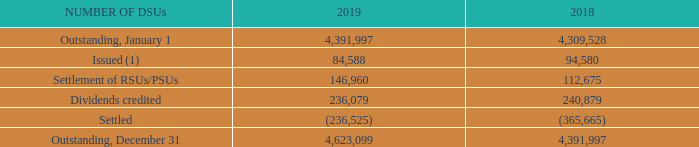DSUs
Eligible bonuses and RSUs/PSUs may be paid in the form of DSUs when executives or other eligible employees elect to or are required to participate in the plan. The value of a DSU at the issuance date is equal to the value of one BCE common share. For non-management directors, compensation is paid in DSUs until the minimum share ownership requirement is met; thereafter, at least 50% of their compensation is paid in DSUs. There are no vesting requirements relating to DSUs. Dividends in the form of additional DSUs are credited to the participant’s account on each dividend payment date and are equivalent in value to the dividends paid on BCE common shares. DSUs are settled when the holder leaves the company.
The following table summarizes the status of outstanding DSUs at December 31, 2019 and 2018.
(1) The weighted average fair value of the DSUs issued was $59 in 2019 and $55 in 2018.
Which years does the table summarize the status of outstanding DSUs? 2019, 2018. What is the value of a DSU at the issuance date? Equal to the value of one bce common share. What is the weighted average fair value of the DSUs issued in 2018? $55. In which year is the amount of Issued DSUs larger? 84,588<94,580
Answer: 2018. What is the fair value of the DSUs issued in 2019? 84,588*$59
Answer: 4990692. What is the average value of the weighted average fair value of the DSUs issued in 2018 and 2019? ($59+$55)/2
Answer: 57. 